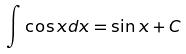Convert formula to latex. <formula><loc_0><loc_0><loc_500><loc_500>\int \cos x d x = \sin x + C</formula> 